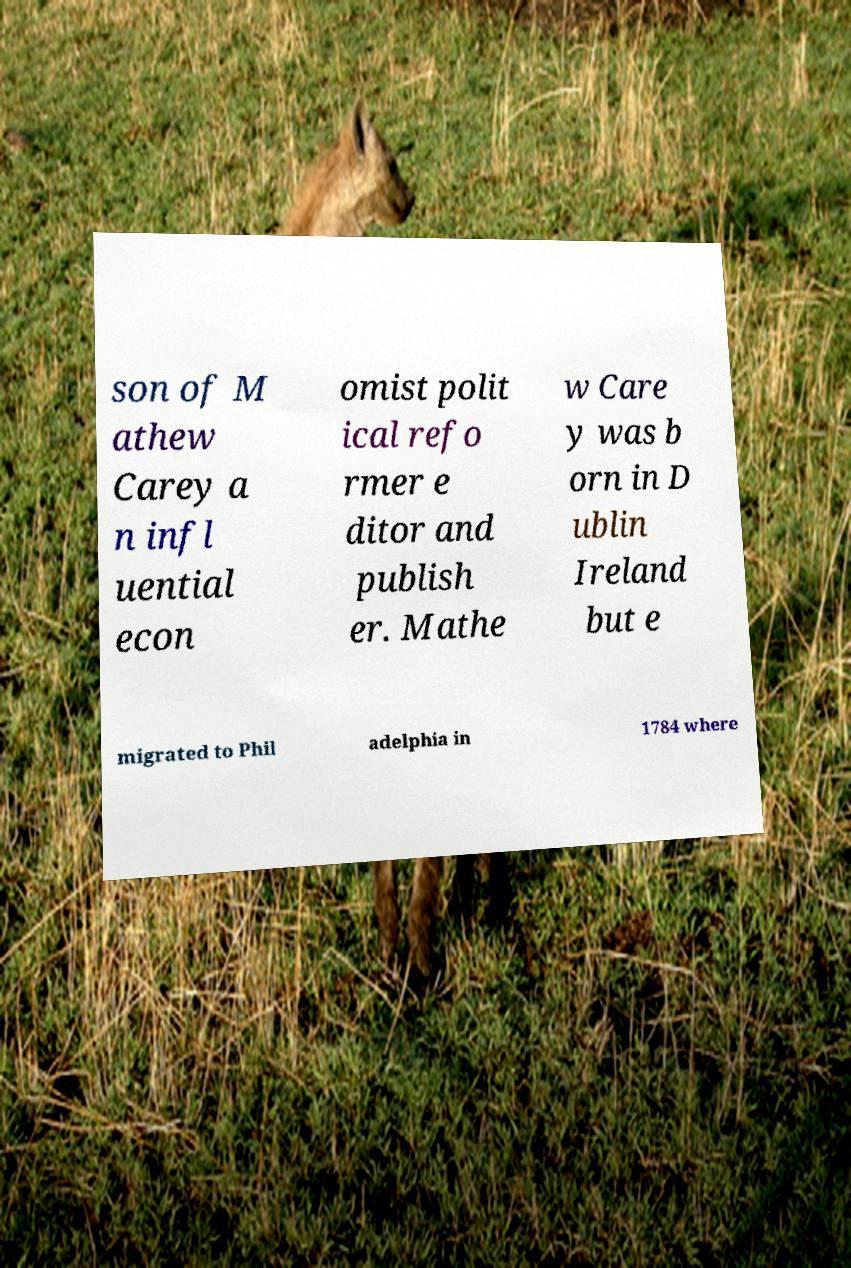Can you accurately transcribe the text from the provided image for me? son of M athew Carey a n infl uential econ omist polit ical refo rmer e ditor and publish er. Mathe w Care y was b orn in D ublin Ireland but e migrated to Phil adelphia in 1784 where 